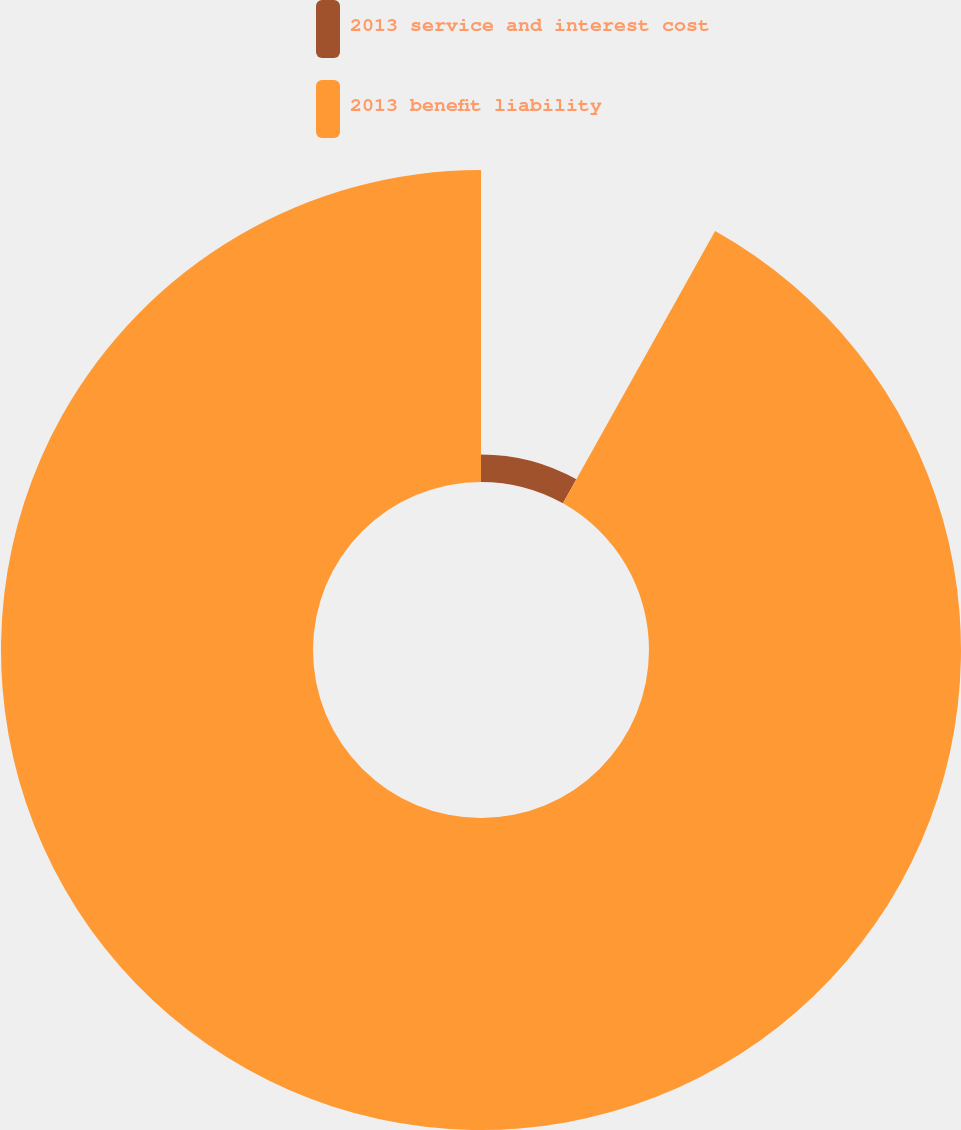Convert chart to OTSL. <chart><loc_0><loc_0><loc_500><loc_500><pie_chart><fcel>2013 service and interest cost<fcel>2013 benefit liability<nl><fcel>8.11%<fcel>91.89%<nl></chart> 